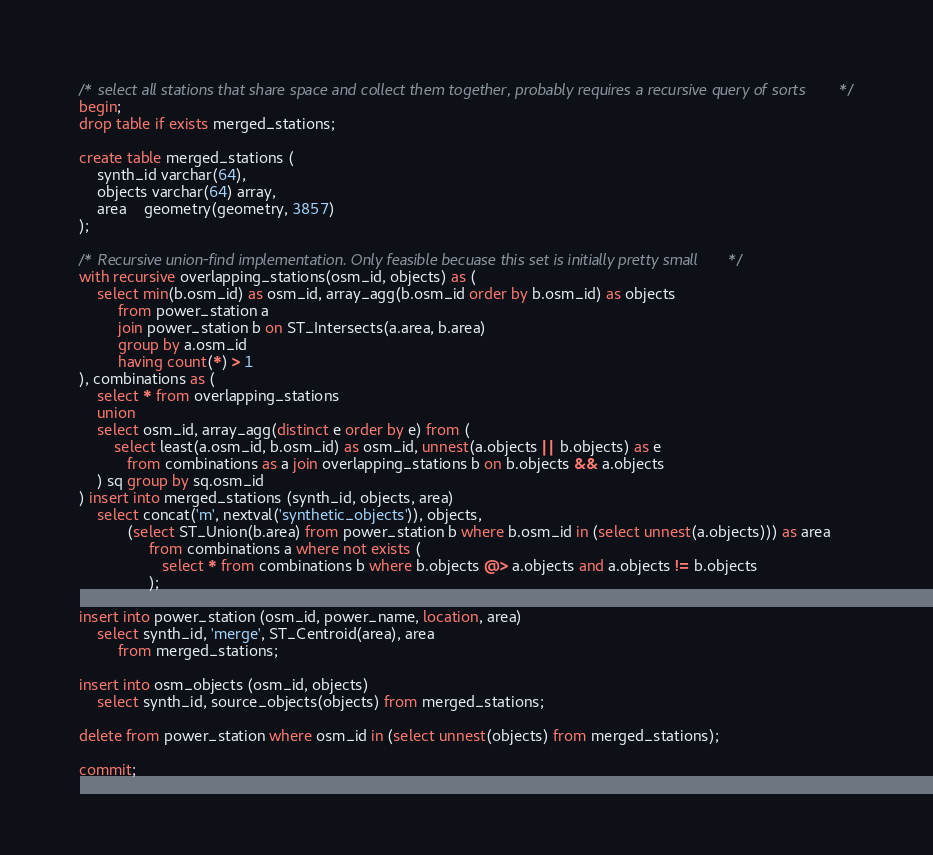Convert code to text. <code><loc_0><loc_0><loc_500><loc_500><_SQL_>/* select all stations that share space and collect them together, probably requires a recursive query of sorts */
begin;
drop table if exists merged_stations;

create table merged_stations (
    synth_id varchar(64),
    objects varchar(64) array,
    area    geometry(geometry, 3857)
);

/* Recursive union-find implementation. Only feasible becuase this set is initially pretty small */
with recursive overlapping_stations(osm_id, objects) as (
    select min(b.osm_id) as osm_id, array_agg(b.osm_id order by b.osm_id) as objects
         from power_station a
         join power_station b on ST_Intersects(a.area, b.area)
         group by a.osm_id
         having count(*) > 1
), combinations as (
    select * from overlapping_stations
    union
    select osm_id, array_agg(distinct e order by e) from (
        select least(a.osm_id, b.osm_id) as osm_id, unnest(a.objects || b.objects) as e
           from combinations as a join overlapping_stations b on b.objects && a.objects
    ) sq group by sq.osm_id
) insert into merged_stations (synth_id, objects, area)
    select concat('m', nextval('synthetic_objects')), objects,
           (select ST_Union(b.area) from power_station b where b.osm_id in (select unnest(a.objects))) as area
                from combinations a where not exists (
                   select * from combinations b where b.objects @> a.objects and a.objects != b.objects
                );

insert into power_station (osm_id, power_name, location, area)
    select synth_id, 'merge', ST_Centroid(area), area
         from merged_stations;

insert into osm_objects (osm_id, objects)
    select synth_id, source_objects(objects) from merged_stations;

delete from power_station where osm_id in (select unnest(objects) from merged_stations);

commit;
</code> 